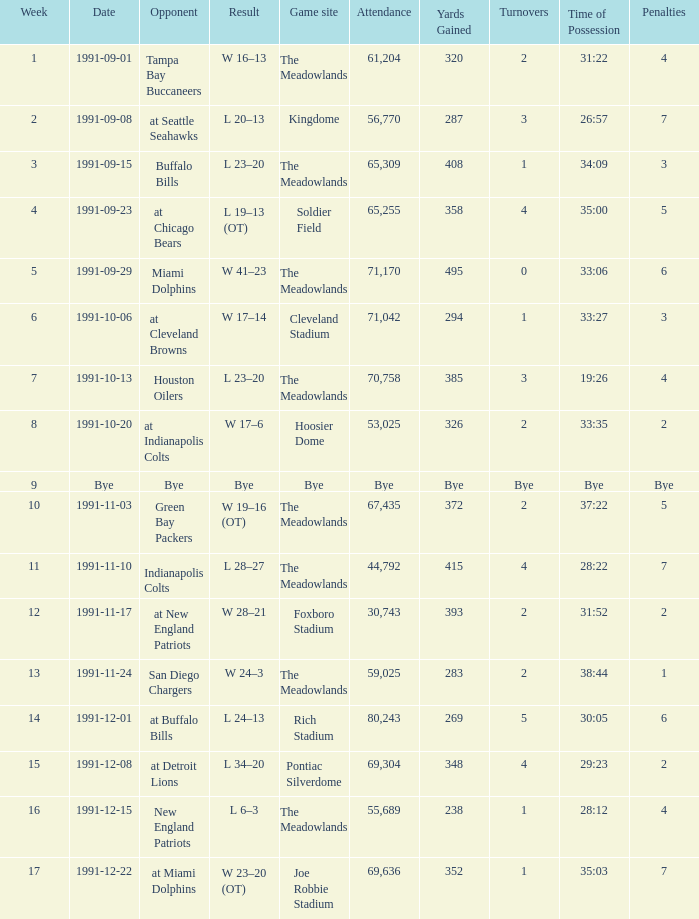What was the Attendance in Week 17? 69636.0. 